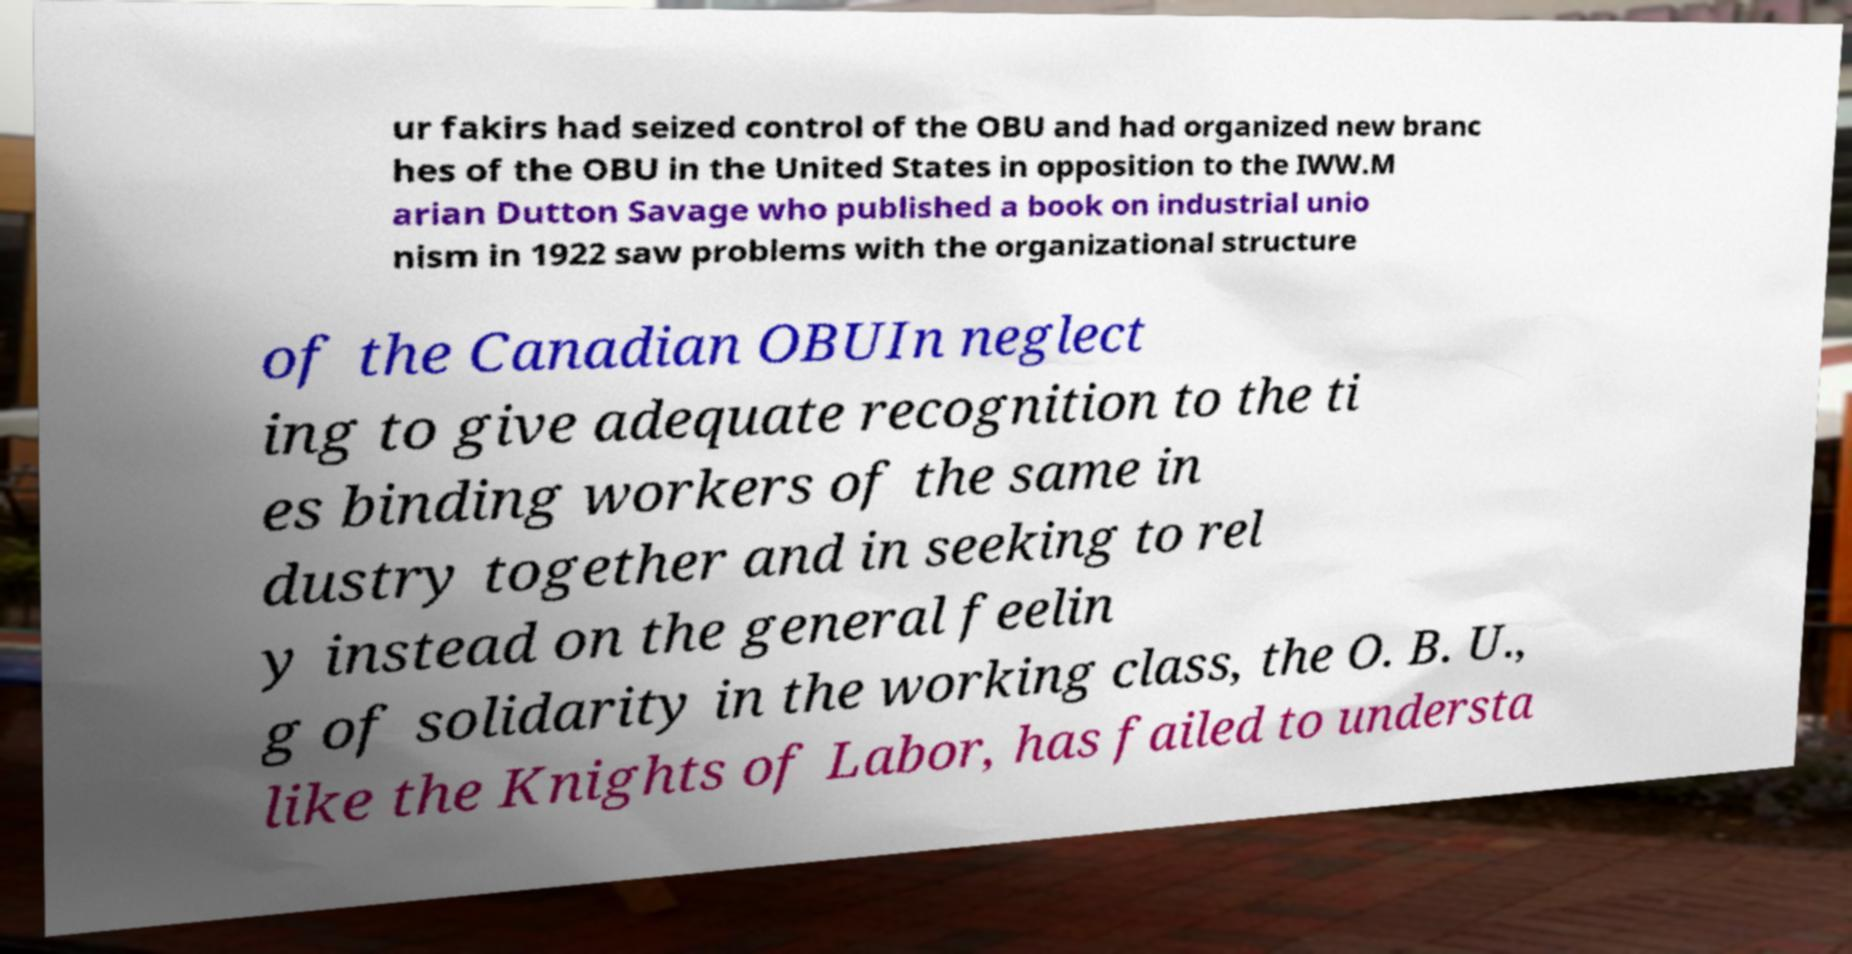Can you accurately transcribe the text from the provided image for me? ur fakirs had seized control of the OBU and had organized new branc hes of the OBU in the United States in opposition to the IWW.M arian Dutton Savage who published a book on industrial unio nism in 1922 saw problems with the organizational structure of the Canadian OBUIn neglect ing to give adequate recognition to the ti es binding workers of the same in dustry together and in seeking to rel y instead on the general feelin g of solidarity in the working class, the O. B. U., like the Knights of Labor, has failed to understa 